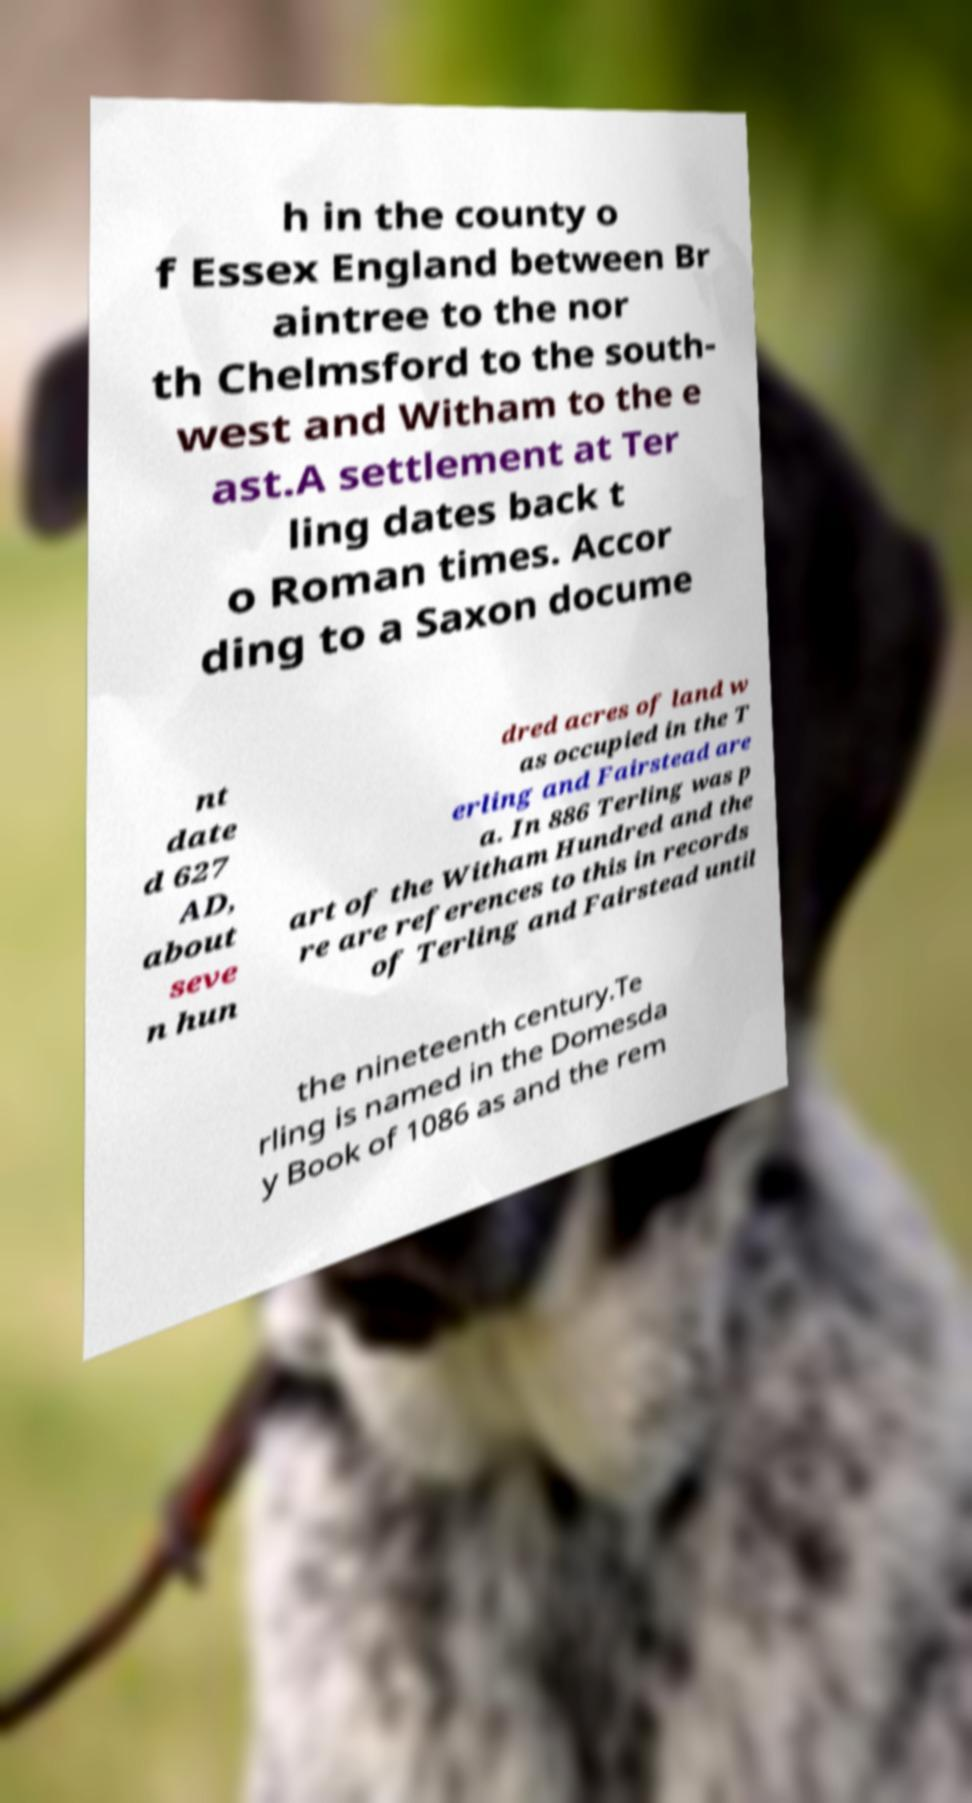Can you read and provide the text displayed in the image?This photo seems to have some interesting text. Can you extract and type it out for me? h in the county o f Essex England between Br aintree to the nor th Chelmsford to the south- west and Witham to the e ast.A settlement at Ter ling dates back t o Roman times. Accor ding to a Saxon docume nt date d 627 AD, about seve n hun dred acres of land w as occupied in the T erling and Fairstead are a. In 886 Terling was p art of the Witham Hundred and the re are references to this in records of Terling and Fairstead until the nineteenth century.Te rling is named in the Domesda y Book of 1086 as and the rem 